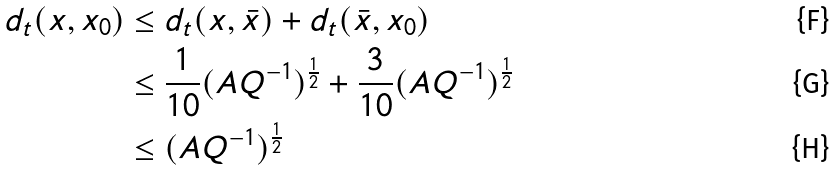Convert formula to latex. <formula><loc_0><loc_0><loc_500><loc_500>d _ { t } ( { x } , x _ { 0 } ) & \leq d _ { t } ( x , \bar { x } ) + d _ { t } ( \bar { x } , x _ { 0 } ) \\ & \leq \frac { 1 } { 1 0 } ( A Q ^ { - 1 } ) ^ { \frac { 1 } { 2 } } + \frac { 3 } { 1 0 } ( A Q ^ { - 1 } ) ^ { \frac { 1 } { 2 } } \\ & \leq ( A Q ^ { - 1 } ) ^ { \frac { 1 } { 2 } }</formula> 